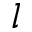Convert formula to latex. <formula><loc_0><loc_0><loc_500><loc_500>l</formula> 